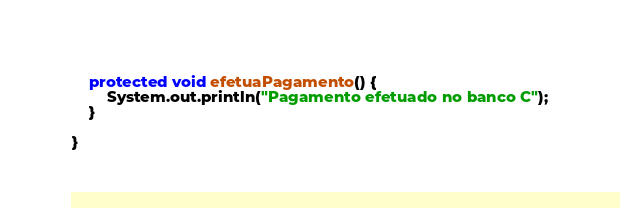Convert code to text. <code><loc_0><loc_0><loc_500><loc_500><_Java_>	protected void efetuaPagamento() {
		System.out.println("Pagamento efetuado no banco C");
	}

}
</code> 